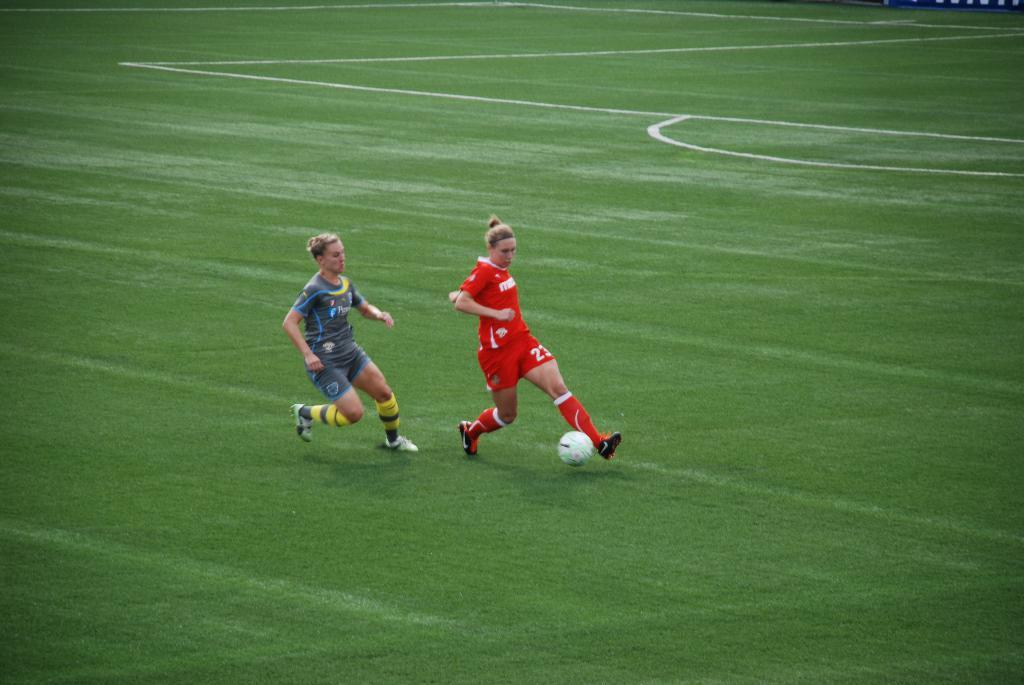<image>
Provide a brief description of the given image. Some girls play soccer with one of them having the number 23 on her shorts. 